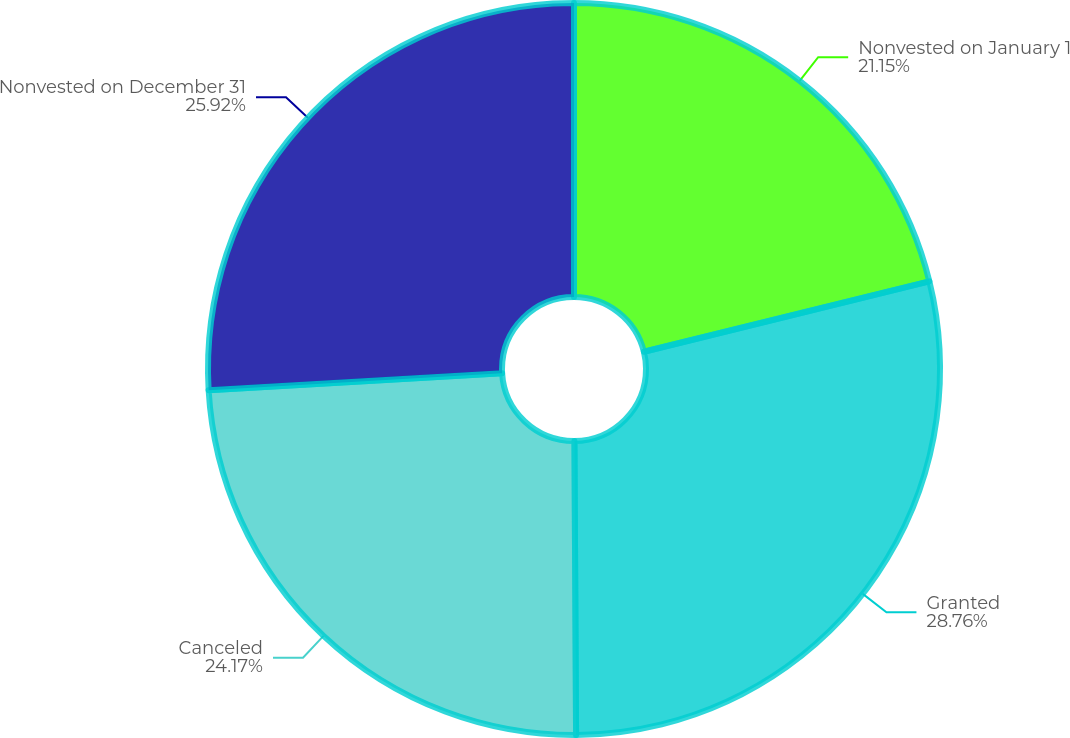<chart> <loc_0><loc_0><loc_500><loc_500><pie_chart><fcel>Nonvested on January 1<fcel>Granted<fcel>Canceled<fcel>Nonvested on December 31<nl><fcel>21.15%<fcel>28.76%<fcel>24.17%<fcel>25.92%<nl></chart> 